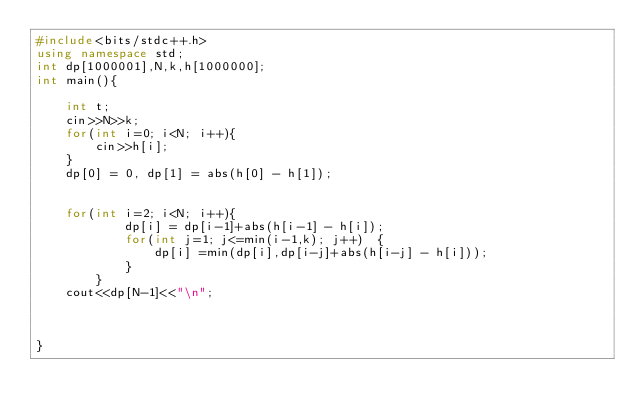Convert code to text. <code><loc_0><loc_0><loc_500><loc_500><_C++_>#include<bits/stdc++.h>
using namespace std;
int dp[1000001],N,k,h[1000000];
int main(){

    int t;
    cin>>N>>k;
    for(int i=0; i<N; i++){
        cin>>h[i];
    }
    dp[0] = 0, dp[1] = abs(h[0] - h[1]);


    for(int i=2; i<N; i++){
            dp[i] = dp[i-1]+abs(h[i-1] - h[i]);
            for(int j=1; j<=min(i-1,k); j++)  {
                dp[i] =min(dp[i],dp[i-j]+abs(h[i-j] - h[i]));
            }
        }
    cout<<dp[N-1]<<"\n";



}
</code> 